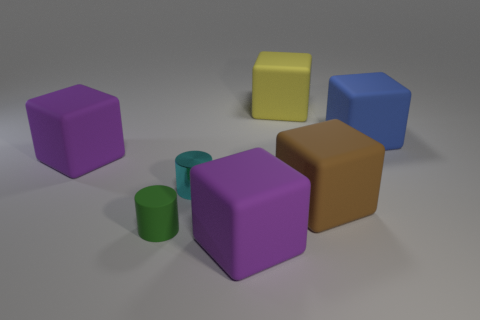What size is the purple thing that is left of the small green thing?
Your response must be concise. Large. There is a purple matte block that is in front of the small cyan cylinder in front of the big blue rubber object; what is its size?
Offer a very short reply. Large. Are there more large red things than small green cylinders?
Keep it short and to the point. No. Are there more blue objects behind the blue block than tiny matte things that are behind the brown matte block?
Offer a terse response. No. There is a matte block that is in front of the small cyan metal cylinder and to the right of the yellow rubber thing; how big is it?
Offer a terse response. Large. How many yellow rubber things are the same size as the brown matte object?
Offer a terse response. 1. There is a rubber object behind the blue rubber cube; is it the same shape as the tiny rubber object?
Your answer should be compact. No. Is the number of big brown blocks behind the big brown cube less than the number of tiny yellow metal cylinders?
Make the answer very short. No. Are there any cylinders of the same color as the small shiny thing?
Provide a short and direct response. No. There is a tiny metal thing; is it the same shape as the matte object to the right of the brown cube?
Your response must be concise. No. 